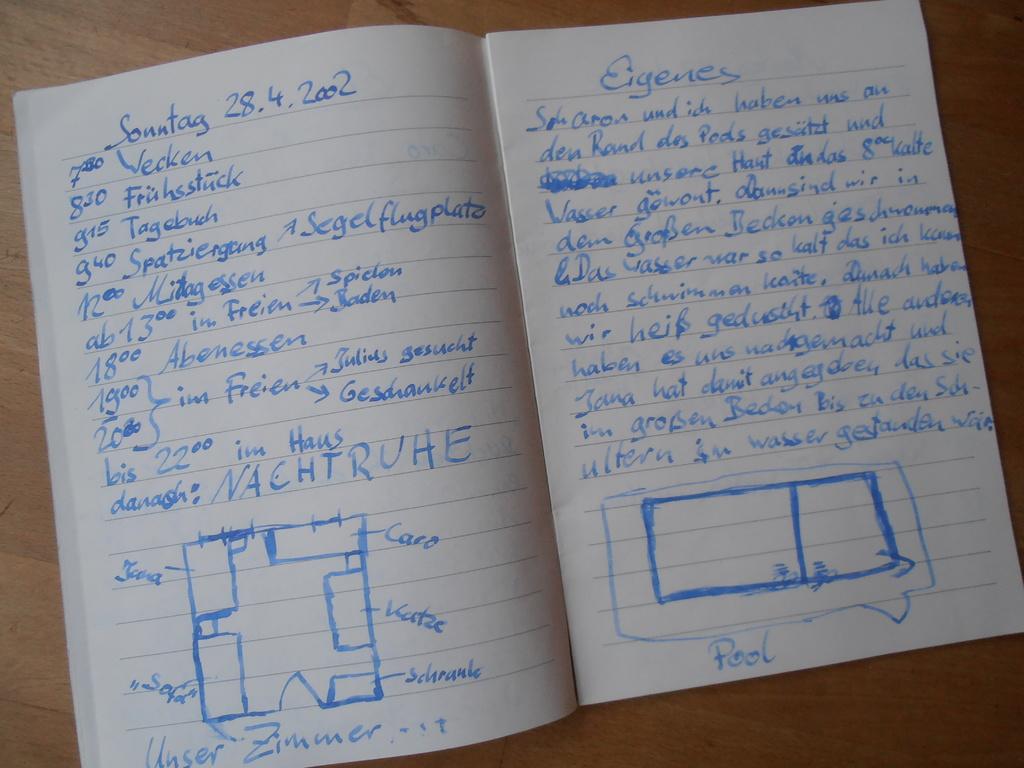What is the date on the page?
Your response must be concise. 28.4.2002. 